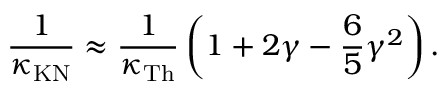Convert formula to latex. <formula><loc_0><loc_0><loc_500><loc_500>\frac { 1 } { \kappa _ { K N } } \approx \frac { 1 } { \kappa _ { T h } } \left ( 1 + 2 \gamma - \frac { 6 } { 5 } \gamma ^ { 2 } \right ) .</formula> 